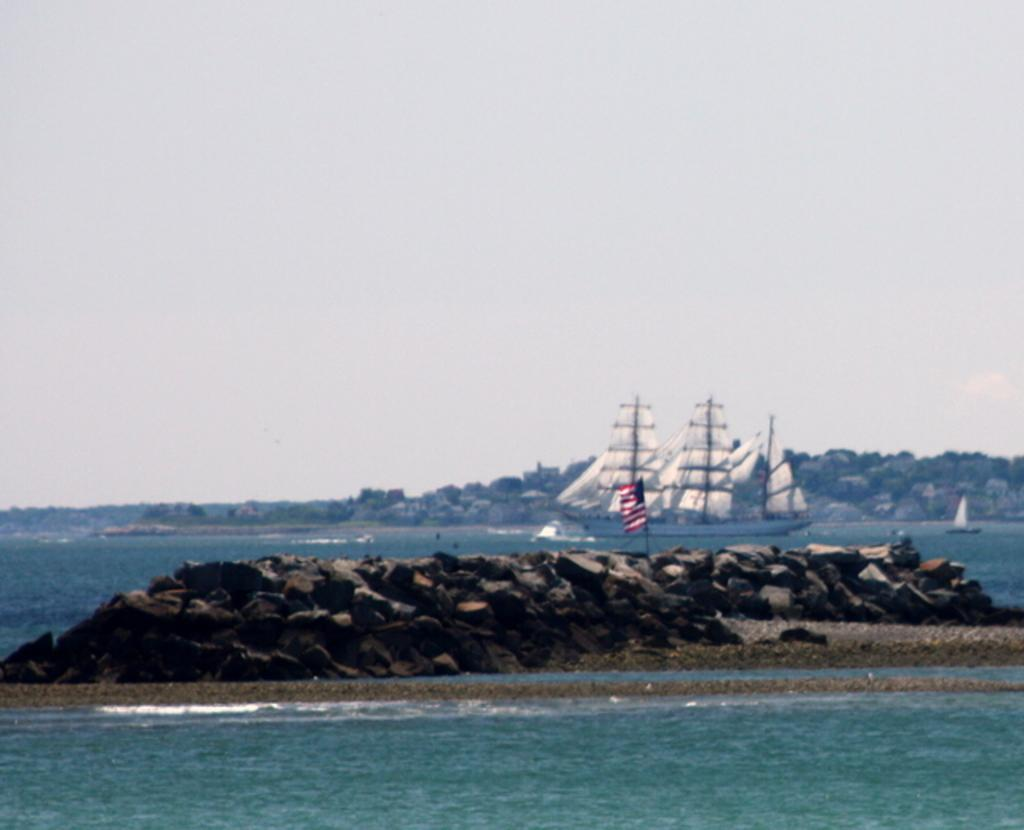What is the main element in the image? There is water in the image. What other objects can be seen in the image? There are rocks, a flag with a pole, and boats on the water in the background. What is visible in the distance in the image? There is a hill in the background of the image. What part of the natural environment is visible in the image? The sky is visible in the image. Reasoning: Let's think step by step by step in order to produce the conversation. We start by identifying the main element in the image, which is the water. Then, we expand the conversation to include other objects that are also visible, such as rocks, the flag with a pole, and boats on the water in the background. We also mention the hill and sky visible in the background. Each question is designed to elicit a specific details about the image that are known from the provided facts. Absurd Question/Answer: What type of bean is being sold at the market in the image? There is no market or beans present in the image. What color is the flag in the image? The flag in the image is not described in the provided facts, so we cannot determine its color. What type of bean is being sold at the market in the image? There is no market or beans present in the image. What color is the flag in the image? The flag in the image is not described in the provided facts, so we cannot determine its color. 